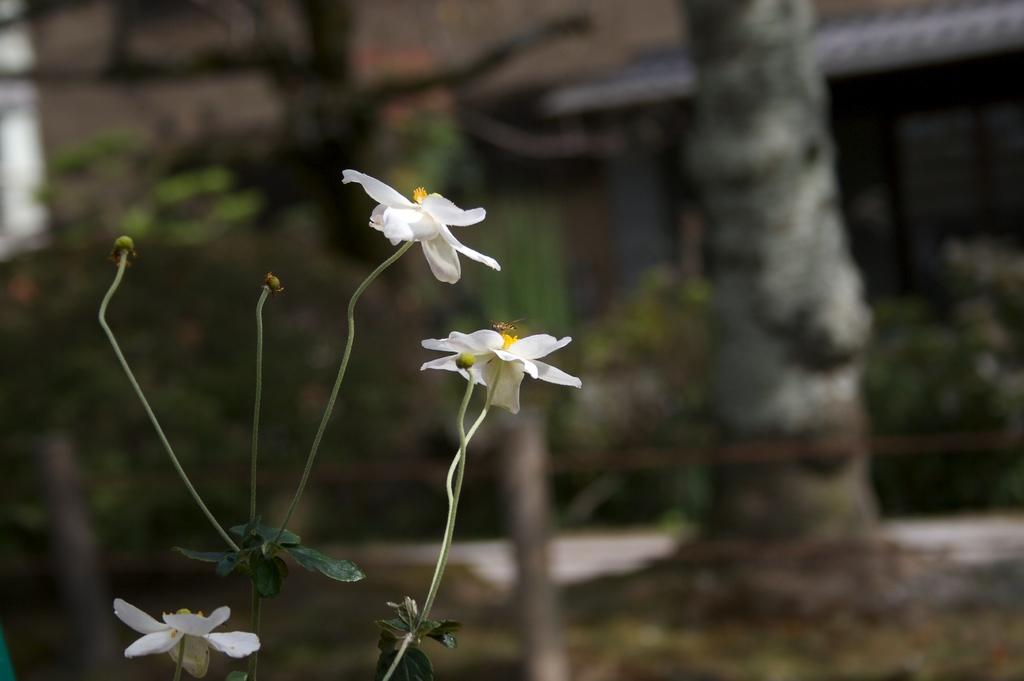What type of flowers can be seen in the image? There are white-colored flowers in the image. What color are the leaves associated with the flowers? There are green-colored leaves in the image. What can be seen in the background of the image? There are trees and a building in the background of the image. How would you describe the quality of the background in the image? The background is blurry in the image. What type of knot is used to secure the cable in the image? There is no knot or cable present in the image. How is the glue being used in the image? There is no glue present in the image. 